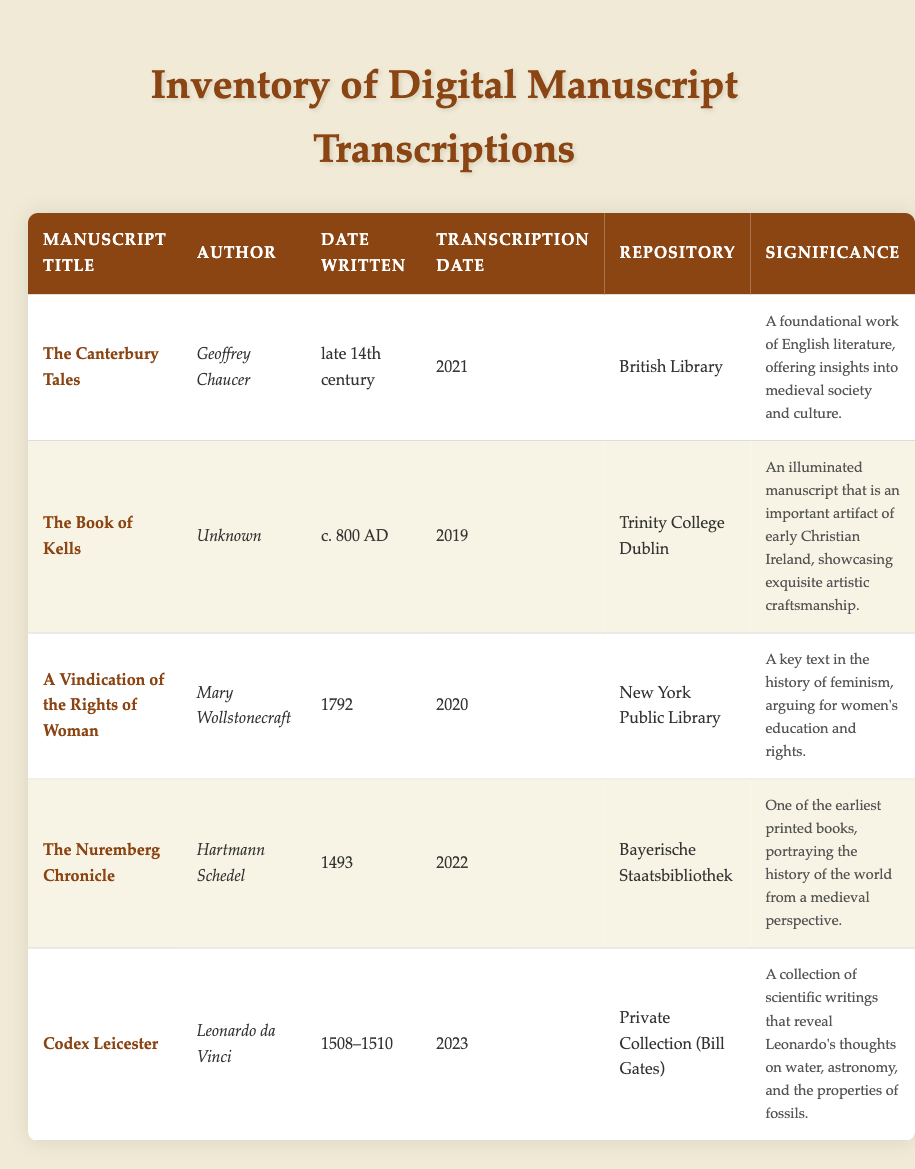What is the title of the manuscript written by Geoffrey Chaucer? According to the table, Geoffrey Chaucer is the author of "The Canterbury Tales." This is explicitly stated in the "Manuscript Title" column.
Answer: The Canterbury Tales Which manuscript was transcribed in 2023? Looking at the "Transcription Date" column, "Codex Leicester" is the only manuscript listed with the transcription date of 2023.
Answer: Codex Leicester Is "A Vindication of the Rights of Woman" part of the British Library's collection? The "Repository" column indicates that "A Vindication of the Rights of Woman" is held at the New York Public Library, not the British Library.
Answer: No How many manuscripts were written in the 15th century? "The Nuremberg Chronicle" was written in 1493, and "Codex Leicester" was written between 1508 and 1510. That gives us a total of 2 manuscripts from the 15th century.
Answer: 2 Which repository has the earliest dated manuscript? The repository holding the earliest manuscript, "The Book of Kells," is Trinity College Dublin, with a creation date of c. 800 AD. This is the earliest date in the entire table.
Answer: Trinity College Dublin What is the significance of "The Canterbury Tales"? The table mentions that the significance of "The Canterbury Tales" is its status as a foundational work of English literature, reflecting insights into medieval society and culture.
Answer: A foundational work of English literature, offering insights into medieval society and culture How many manuscripts were transcribed after 2020? The manuscripts transcribed after 2020 are "The Nuremberg Chronicle" (2022) and "Codex Leicester" (2023). This results in a total of 2 manuscripts that fall into this category.
Answer: 2 Is there any manuscript that showcases early Christian artistic craftsmanship? Yes, "The Book of Kells" is noted for showcasing exquisite artistic craftsmanship as an illuminated manuscript of early Christian Ireland.
Answer: Yes Which author wrote the manuscript transcribed in 2019? The table indicates that "The Book of Kells," transcribed in 2019, has an unknown author, which is consistent with its historical ambiguity.
Answer: Unknown 